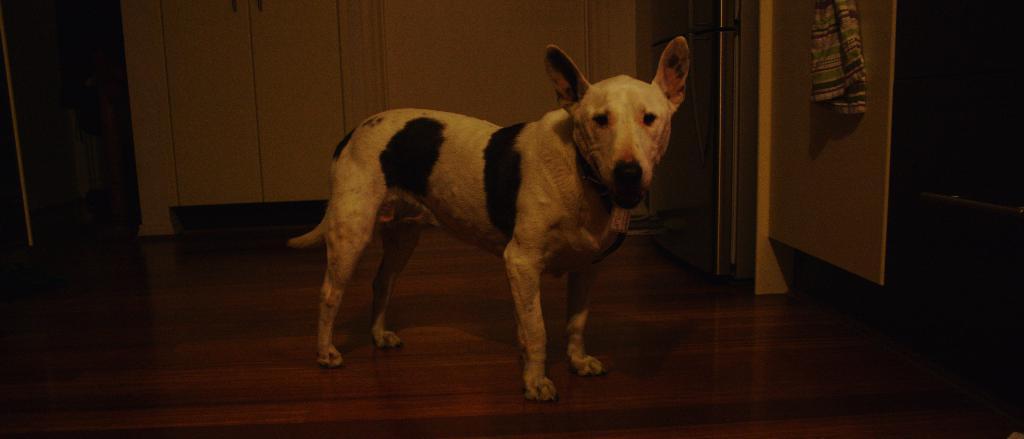Can you describe this image briefly? In this picture there is a dog standing and there is a cloth placed on an object in the right corner and there is a refrigerator beside it and there are some other objects in the background. 